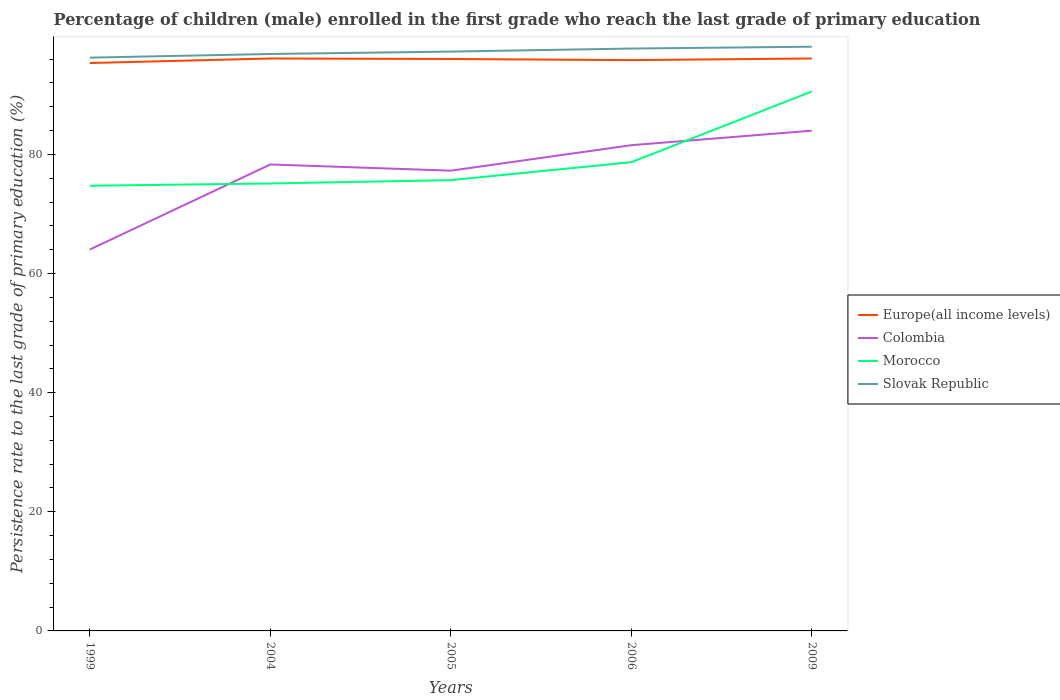How many different coloured lines are there?
Ensure brevity in your answer.  4. Is the number of lines equal to the number of legend labels?
Ensure brevity in your answer.  Yes. Across all years, what is the maximum persistence rate of children in Slovak Republic?
Offer a very short reply. 96.26. In which year was the persistence rate of children in Morocco maximum?
Provide a succinct answer. 1999. What is the total persistence rate of children in Morocco in the graph?
Offer a terse response. -3.01. What is the difference between the highest and the second highest persistence rate of children in Europe(all income levels)?
Your response must be concise. 0.76. How many years are there in the graph?
Your response must be concise. 5. What is the difference between two consecutive major ticks on the Y-axis?
Make the answer very short. 20. Are the values on the major ticks of Y-axis written in scientific E-notation?
Offer a very short reply. No. Does the graph contain any zero values?
Your answer should be compact. No. Does the graph contain grids?
Make the answer very short. No. How many legend labels are there?
Offer a terse response. 4. How are the legend labels stacked?
Your answer should be compact. Vertical. What is the title of the graph?
Keep it short and to the point. Percentage of children (male) enrolled in the first grade who reach the last grade of primary education. What is the label or title of the Y-axis?
Offer a terse response. Persistence rate to the last grade of primary education (%). What is the Persistence rate to the last grade of primary education (%) of Europe(all income levels) in 1999?
Your answer should be compact. 95.35. What is the Persistence rate to the last grade of primary education (%) in Colombia in 1999?
Ensure brevity in your answer.  64.04. What is the Persistence rate to the last grade of primary education (%) in Morocco in 1999?
Offer a very short reply. 74.75. What is the Persistence rate to the last grade of primary education (%) of Slovak Republic in 1999?
Make the answer very short. 96.26. What is the Persistence rate to the last grade of primary education (%) in Europe(all income levels) in 2004?
Make the answer very short. 96.11. What is the Persistence rate to the last grade of primary education (%) in Colombia in 2004?
Keep it short and to the point. 78.32. What is the Persistence rate to the last grade of primary education (%) of Morocco in 2004?
Ensure brevity in your answer.  75.13. What is the Persistence rate to the last grade of primary education (%) in Slovak Republic in 2004?
Your answer should be compact. 96.87. What is the Persistence rate to the last grade of primary education (%) in Europe(all income levels) in 2005?
Make the answer very short. 96.03. What is the Persistence rate to the last grade of primary education (%) of Colombia in 2005?
Make the answer very short. 77.28. What is the Persistence rate to the last grade of primary education (%) of Morocco in 2005?
Ensure brevity in your answer.  75.69. What is the Persistence rate to the last grade of primary education (%) in Slovak Republic in 2005?
Provide a short and direct response. 97.27. What is the Persistence rate to the last grade of primary education (%) in Europe(all income levels) in 2006?
Your response must be concise. 95.84. What is the Persistence rate to the last grade of primary education (%) of Colombia in 2006?
Offer a very short reply. 81.56. What is the Persistence rate to the last grade of primary education (%) in Morocco in 2006?
Offer a very short reply. 78.7. What is the Persistence rate to the last grade of primary education (%) of Slovak Republic in 2006?
Offer a terse response. 97.78. What is the Persistence rate to the last grade of primary education (%) of Europe(all income levels) in 2009?
Your response must be concise. 96.11. What is the Persistence rate to the last grade of primary education (%) in Colombia in 2009?
Make the answer very short. 83.99. What is the Persistence rate to the last grade of primary education (%) in Morocco in 2009?
Ensure brevity in your answer.  90.58. What is the Persistence rate to the last grade of primary education (%) in Slovak Republic in 2009?
Ensure brevity in your answer.  98.09. Across all years, what is the maximum Persistence rate to the last grade of primary education (%) in Europe(all income levels)?
Provide a succinct answer. 96.11. Across all years, what is the maximum Persistence rate to the last grade of primary education (%) in Colombia?
Ensure brevity in your answer.  83.99. Across all years, what is the maximum Persistence rate to the last grade of primary education (%) of Morocco?
Keep it short and to the point. 90.58. Across all years, what is the maximum Persistence rate to the last grade of primary education (%) in Slovak Republic?
Ensure brevity in your answer.  98.09. Across all years, what is the minimum Persistence rate to the last grade of primary education (%) of Europe(all income levels)?
Your response must be concise. 95.35. Across all years, what is the minimum Persistence rate to the last grade of primary education (%) in Colombia?
Provide a short and direct response. 64.04. Across all years, what is the minimum Persistence rate to the last grade of primary education (%) of Morocco?
Offer a terse response. 74.75. Across all years, what is the minimum Persistence rate to the last grade of primary education (%) in Slovak Republic?
Ensure brevity in your answer.  96.26. What is the total Persistence rate to the last grade of primary education (%) of Europe(all income levels) in the graph?
Make the answer very short. 479.45. What is the total Persistence rate to the last grade of primary education (%) of Colombia in the graph?
Offer a terse response. 385.19. What is the total Persistence rate to the last grade of primary education (%) of Morocco in the graph?
Give a very brief answer. 394.85. What is the total Persistence rate to the last grade of primary education (%) of Slovak Republic in the graph?
Make the answer very short. 486.27. What is the difference between the Persistence rate to the last grade of primary education (%) of Europe(all income levels) in 1999 and that in 2004?
Offer a very short reply. -0.76. What is the difference between the Persistence rate to the last grade of primary education (%) in Colombia in 1999 and that in 2004?
Provide a succinct answer. -14.28. What is the difference between the Persistence rate to the last grade of primary education (%) of Morocco in 1999 and that in 2004?
Provide a short and direct response. -0.38. What is the difference between the Persistence rate to the last grade of primary education (%) in Slovak Republic in 1999 and that in 2004?
Offer a very short reply. -0.61. What is the difference between the Persistence rate to the last grade of primary education (%) of Europe(all income levels) in 1999 and that in 2005?
Make the answer very short. -0.68. What is the difference between the Persistence rate to the last grade of primary education (%) of Colombia in 1999 and that in 2005?
Your answer should be very brief. -13.24. What is the difference between the Persistence rate to the last grade of primary education (%) of Morocco in 1999 and that in 2005?
Offer a terse response. -0.94. What is the difference between the Persistence rate to the last grade of primary education (%) in Slovak Republic in 1999 and that in 2005?
Your response must be concise. -1.02. What is the difference between the Persistence rate to the last grade of primary education (%) in Europe(all income levels) in 1999 and that in 2006?
Provide a succinct answer. -0.49. What is the difference between the Persistence rate to the last grade of primary education (%) of Colombia in 1999 and that in 2006?
Your answer should be compact. -17.52. What is the difference between the Persistence rate to the last grade of primary education (%) in Morocco in 1999 and that in 2006?
Make the answer very short. -3.95. What is the difference between the Persistence rate to the last grade of primary education (%) of Slovak Republic in 1999 and that in 2006?
Give a very brief answer. -1.53. What is the difference between the Persistence rate to the last grade of primary education (%) in Europe(all income levels) in 1999 and that in 2009?
Keep it short and to the point. -0.76. What is the difference between the Persistence rate to the last grade of primary education (%) of Colombia in 1999 and that in 2009?
Give a very brief answer. -19.95. What is the difference between the Persistence rate to the last grade of primary education (%) in Morocco in 1999 and that in 2009?
Ensure brevity in your answer.  -15.83. What is the difference between the Persistence rate to the last grade of primary education (%) of Slovak Republic in 1999 and that in 2009?
Your answer should be compact. -1.84. What is the difference between the Persistence rate to the last grade of primary education (%) in Europe(all income levels) in 2004 and that in 2005?
Your answer should be compact. 0.08. What is the difference between the Persistence rate to the last grade of primary education (%) in Colombia in 2004 and that in 2005?
Provide a succinct answer. 1.04. What is the difference between the Persistence rate to the last grade of primary education (%) in Morocco in 2004 and that in 2005?
Provide a succinct answer. -0.56. What is the difference between the Persistence rate to the last grade of primary education (%) of Slovak Republic in 2004 and that in 2005?
Ensure brevity in your answer.  -0.41. What is the difference between the Persistence rate to the last grade of primary education (%) in Europe(all income levels) in 2004 and that in 2006?
Provide a succinct answer. 0.27. What is the difference between the Persistence rate to the last grade of primary education (%) of Colombia in 2004 and that in 2006?
Offer a very short reply. -3.24. What is the difference between the Persistence rate to the last grade of primary education (%) of Morocco in 2004 and that in 2006?
Ensure brevity in your answer.  -3.57. What is the difference between the Persistence rate to the last grade of primary education (%) in Slovak Republic in 2004 and that in 2006?
Provide a short and direct response. -0.91. What is the difference between the Persistence rate to the last grade of primary education (%) in Europe(all income levels) in 2004 and that in 2009?
Provide a short and direct response. -0. What is the difference between the Persistence rate to the last grade of primary education (%) in Colombia in 2004 and that in 2009?
Your response must be concise. -5.67. What is the difference between the Persistence rate to the last grade of primary education (%) of Morocco in 2004 and that in 2009?
Offer a very short reply. -15.45. What is the difference between the Persistence rate to the last grade of primary education (%) of Slovak Republic in 2004 and that in 2009?
Provide a succinct answer. -1.22. What is the difference between the Persistence rate to the last grade of primary education (%) in Europe(all income levels) in 2005 and that in 2006?
Your response must be concise. 0.19. What is the difference between the Persistence rate to the last grade of primary education (%) in Colombia in 2005 and that in 2006?
Provide a succinct answer. -4.28. What is the difference between the Persistence rate to the last grade of primary education (%) of Morocco in 2005 and that in 2006?
Make the answer very short. -3.01. What is the difference between the Persistence rate to the last grade of primary education (%) of Slovak Republic in 2005 and that in 2006?
Your response must be concise. -0.51. What is the difference between the Persistence rate to the last grade of primary education (%) in Europe(all income levels) in 2005 and that in 2009?
Keep it short and to the point. -0.09. What is the difference between the Persistence rate to the last grade of primary education (%) of Colombia in 2005 and that in 2009?
Your answer should be compact. -6.71. What is the difference between the Persistence rate to the last grade of primary education (%) in Morocco in 2005 and that in 2009?
Give a very brief answer. -14.89. What is the difference between the Persistence rate to the last grade of primary education (%) of Slovak Republic in 2005 and that in 2009?
Your answer should be compact. -0.82. What is the difference between the Persistence rate to the last grade of primary education (%) of Europe(all income levels) in 2006 and that in 2009?
Offer a terse response. -0.28. What is the difference between the Persistence rate to the last grade of primary education (%) of Colombia in 2006 and that in 2009?
Your response must be concise. -2.44. What is the difference between the Persistence rate to the last grade of primary education (%) of Morocco in 2006 and that in 2009?
Give a very brief answer. -11.88. What is the difference between the Persistence rate to the last grade of primary education (%) in Slovak Republic in 2006 and that in 2009?
Provide a short and direct response. -0.31. What is the difference between the Persistence rate to the last grade of primary education (%) of Europe(all income levels) in 1999 and the Persistence rate to the last grade of primary education (%) of Colombia in 2004?
Your response must be concise. 17.03. What is the difference between the Persistence rate to the last grade of primary education (%) of Europe(all income levels) in 1999 and the Persistence rate to the last grade of primary education (%) of Morocco in 2004?
Ensure brevity in your answer.  20.22. What is the difference between the Persistence rate to the last grade of primary education (%) in Europe(all income levels) in 1999 and the Persistence rate to the last grade of primary education (%) in Slovak Republic in 2004?
Your response must be concise. -1.52. What is the difference between the Persistence rate to the last grade of primary education (%) of Colombia in 1999 and the Persistence rate to the last grade of primary education (%) of Morocco in 2004?
Offer a terse response. -11.09. What is the difference between the Persistence rate to the last grade of primary education (%) of Colombia in 1999 and the Persistence rate to the last grade of primary education (%) of Slovak Republic in 2004?
Keep it short and to the point. -32.83. What is the difference between the Persistence rate to the last grade of primary education (%) in Morocco in 1999 and the Persistence rate to the last grade of primary education (%) in Slovak Republic in 2004?
Provide a short and direct response. -22.12. What is the difference between the Persistence rate to the last grade of primary education (%) in Europe(all income levels) in 1999 and the Persistence rate to the last grade of primary education (%) in Colombia in 2005?
Your answer should be very brief. 18.07. What is the difference between the Persistence rate to the last grade of primary education (%) of Europe(all income levels) in 1999 and the Persistence rate to the last grade of primary education (%) of Morocco in 2005?
Provide a short and direct response. 19.66. What is the difference between the Persistence rate to the last grade of primary education (%) in Europe(all income levels) in 1999 and the Persistence rate to the last grade of primary education (%) in Slovak Republic in 2005?
Offer a terse response. -1.92. What is the difference between the Persistence rate to the last grade of primary education (%) in Colombia in 1999 and the Persistence rate to the last grade of primary education (%) in Morocco in 2005?
Offer a very short reply. -11.65. What is the difference between the Persistence rate to the last grade of primary education (%) of Colombia in 1999 and the Persistence rate to the last grade of primary education (%) of Slovak Republic in 2005?
Offer a very short reply. -33.24. What is the difference between the Persistence rate to the last grade of primary education (%) in Morocco in 1999 and the Persistence rate to the last grade of primary education (%) in Slovak Republic in 2005?
Keep it short and to the point. -22.52. What is the difference between the Persistence rate to the last grade of primary education (%) of Europe(all income levels) in 1999 and the Persistence rate to the last grade of primary education (%) of Colombia in 2006?
Offer a very short reply. 13.8. What is the difference between the Persistence rate to the last grade of primary education (%) in Europe(all income levels) in 1999 and the Persistence rate to the last grade of primary education (%) in Morocco in 2006?
Provide a succinct answer. 16.65. What is the difference between the Persistence rate to the last grade of primary education (%) of Europe(all income levels) in 1999 and the Persistence rate to the last grade of primary education (%) of Slovak Republic in 2006?
Provide a short and direct response. -2.43. What is the difference between the Persistence rate to the last grade of primary education (%) of Colombia in 1999 and the Persistence rate to the last grade of primary education (%) of Morocco in 2006?
Offer a terse response. -14.66. What is the difference between the Persistence rate to the last grade of primary education (%) of Colombia in 1999 and the Persistence rate to the last grade of primary education (%) of Slovak Republic in 2006?
Provide a succinct answer. -33.74. What is the difference between the Persistence rate to the last grade of primary education (%) in Morocco in 1999 and the Persistence rate to the last grade of primary education (%) in Slovak Republic in 2006?
Give a very brief answer. -23.03. What is the difference between the Persistence rate to the last grade of primary education (%) in Europe(all income levels) in 1999 and the Persistence rate to the last grade of primary education (%) in Colombia in 2009?
Provide a short and direct response. 11.36. What is the difference between the Persistence rate to the last grade of primary education (%) in Europe(all income levels) in 1999 and the Persistence rate to the last grade of primary education (%) in Morocco in 2009?
Offer a very short reply. 4.77. What is the difference between the Persistence rate to the last grade of primary education (%) of Europe(all income levels) in 1999 and the Persistence rate to the last grade of primary education (%) of Slovak Republic in 2009?
Offer a very short reply. -2.74. What is the difference between the Persistence rate to the last grade of primary education (%) in Colombia in 1999 and the Persistence rate to the last grade of primary education (%) in Morocco in 2009?
Offer a terse response. -26.54. What is the difference between the Persistence rate to the last grade of primary education (%) of Colombia in 1999 and the Persistence rate to the last grade of primary education (%) of Slovak Republic in 2009?
Your response must be concise. -34.05. What is the difference between the Persistence rate to the last grade of primary education (%) in Morocco in 1999 and the Persistence rate to the last grade of primary education (%) in Slovak Republic in 2009?
Give a very brief answer. -23.34. What is the difference between the Persistence rate to the last grade of primary education (%) of Europe(all income levels) in 2004 and the Persistence rate to the last grade of primary education (%) of Colombia in 2005?
Offer a very short reply. 18.83. What is the difference between the Persistence rate to the last grade of primary education (%) in Europe(all income levels) in 2004 and the Persistence rate to the last grade of primary education (%) in Morocco in 2005?
Give a very brief answer. 20.42. What is the difference between the Persistence rate to the last grade of primary education (%) in Europe(all income levels) in 2004 and the Persistence rate to the last grade of primary education (%) in Slovak Republic in 2005?
Your response must be concise. -1.16. What is the difference between the Persistence rate to the last grade of primary education (%) of Colombia in 2004 and the Persistence rate to the last grade of primary education (%) of Morocco in 2005?
Keep it short and to the point. 2.63. What is the difference between the Persistence rate to the last grade of primary education (%) in Colombia in 2004 and the Persistence rate to the last grade of primary education (%) in Slovak Republic in 2005?
Offer a very short reply. -18.96. What is the difference between the Persistence rate to the last grade of primary education (%) in Morocco in 2004 and the Persistence rate to the last grade of primary education (%) in Slovak Republic in 2005?
Your answer should be compact. -22.15. What is the difference between the Persistence rate to the last grade of primary education (%) in Europe(all income levels) in 2004 and the Persistence rate to the last grade of primary education (%) in Colombia in 2006?
Give a very brief answer. 14.55. What is the difference between the Persistence rate to the last grade of primary education (%) of Europe(all income levels) in 2004 and the Persistence rate to the last grade of primary education (%) of Morocco in 2006?
Provide a short and direct response. 17.41. What is the difference between the Persistence rate to the last grade of primary education (%) of Europe(all income levels) in 2004 and the Persistence rate to the last grade of primary education (%) of Slovak Republic in 2006?
Ensure brevity in your answer.  -1.67. What is the difference between the Persistence rate to the last grade of primary education (%) of Colombia in 2004 and the Persistence rate to the last grade of primary education (%) of Morocco in 2006?
Offer a very short reply. -0.38. What is the difference between the Persistence rate to the last grade of primary education (%) of Colombia in 2004 and the Persistence rate to the last grade of primary education (%) of Slovak Republic in 2006?
Your answer should be very brief. -19.46. What is the difference between the Persistence rate to the last grade of primary education (%) in Morocco in 2004 and the Persistence rate to the last grade of primary education (%) in Slovak Republic in 2006?
Offer a terse response. -22.65. What is the difference between the Persistence rate to the last grade of primary education (%) of Europe(all income levels) in 2004 and the Persistence rate to the last grade of primary education (%) of Colombia in 2009?
Offer a terse response. 12.12. What is the difference between the Persistence rate to the last grade of primary education (%) in Europe(all income levels) in 2004 and the Persistence rate to the last grade of primary education (%) in Morocco in 2009?
Your response must be concise. 5.53. What is the difference between the Persistence rate to the last grade of primary education (%) in Europe(all income levels) in 2004 and the Persistence rate to the last grade of primary education (%) in Slovak Republic in 2009?
Provide a short and direct response. -1.98. What is the difference between the Persistence rate to the last grade of primary education (%) of Colombia in 2004 and the Persistence rate to the last grade of primary education (%) of Morocco in 2009?
Offer a very short reply. -12.26. What is the difference between the Persistence rate to the last grade of primary education (%) of Colombia in 2004 and the Persistence rate to the last grade of primary education (%) of Slovak Republic in 2009?
Provide a succinct answer. -19.77. What is the difference between the Persistence rate to the last grade of primary education (%) in Morocco in 2004 and the Persistence rate to the last grade of primary education (%) in Slovak Republic in 2009?
Offer a terse response. -22.96. What is the difference between the Persistence rate to the last grade of primary education (%) in Europe(all income levels) in 2005 and the Persistence rate to the last grade of primary education (%) in Colombia in 2006?
Your answer should be compact. 14.47. What is the difference between the Persistence rate to the last grade of primary education (%) of Europe(all income levels) in 2005 and the Persistence rate to the last grade of primary education (%) of Morocco in 2006?
Give a very brief answer. 17.33. What is the difference between the Persistence rate to the last grade of primary education (%) of Europe(all income levels) in 2005 and the Persistence rate to the last grade of primary education (%) of Slovak Republic in 2006?
Provide a short and direct response. -1.75. What is the difference between the Persistence rate to the last grade of primary education (%) of Colombia in 2005 and the Persistence rate to the last grade of primary education (%) of Morocco in 2006?
Your answer should be very brief. -1.42. What is the difference between the Persistence rate to the last grade of primary education (%) in Colombia in 2005 and the Persistence rate to the last grade of primary education (%) in Slovak Republic in 2006?
Provide a short and direct response. -20.5. What is the difference between the Persistence rate to the last grade of primary education (%) of Morocco in 2005 and the Persistence rate to the last grade of primary education (%) of Slovak Republic in 2006?
Provide a short and direct response. -22.09. What is the difference between the Persistence rate to the last grade of primary education (%) of Europe(all income levels) in 2005 and the Persistence rate to the last grade of primary education (%) of Colombia in 2009?
Your answer should be very brief. 12.04. What is the difference between the Persistence rate to the last grade of primary education (%) in Europe(all income levels) in 2005 and the Persistence rate to the last grade of primary education (%) in Morocco in 2009?
Offer a terse response. 5.45. What is the difference between the Persistence rate to the last grade of primary education (%) in Europe(all income levels) in 2005 and the Persistence rate to the last grade of primary education (%) in Slovak Republic in 2009?
Offer a terse response. -2.06. What is the difference between the Persistence rate to the last grade of primary education (%) in Colombia in 2005 and the Persistence rate to the last grade of primary education (%) in Morocco in 2009?
Give a very brief answer. -13.3. What is the difference between the Persistence rate to the last grade of primary education (%) of Colombia in 2005 and the Persistence rate to the last grade of primary education (%) of Slovak Republic in 2009?
Give a very brief answer. -20.81. What is the difference between the Persistence rate to the last grade of primary education (%) in Morocco in 2005 and the Persistence rate to the last grade of primary education (%) in Slovak Republic in 2009?
Your answer should be very brief. -22.4. What is the difference between the Persistence rate to the last grade of primary education (%) of Europe(all income levels) in 2006 and the Persistence rate to the last grade of primary education (%) of Colombia in 2009?
Ensure brevity in your answer.  11.85. What is the difference between the Persistence rate to the last grade of primary education (%) of Europe(all income levels) in 2006 and the Persistence rate to the last grade of primary education (%) of Morocco in 2009?
Make the answer very short. 5.26. What is the difference between the Persistence rate to the last grade of primary education (%) of Europe(all income levels) in 2006 and the Persistence rate to the last grade of primary education (%) of Slovak Republic in 2009?
Make the answer very short. -2.25. What is the difference between the Persistence rate to the last grade of primary education (%) in Colombia in 2006 and the Persistence rate to the last grade of primary education (%) in Morocco in 2009?
Provide a short and direct response. -9.02. What is the difference between the Persistence rate to the last grade of primary education (%) in Colombia in 2006 and the Persistence rate to the last grade of primary education (%) in Slovak Republic in 2009?
Offer a terse response. -16.53. What is the difference between the Persistence rate to the last grade of primary education (%) in Morocco in 2006 and the Persistence rate to the last grade of primary education (%) in Slovak Republic in 2009?
Offer a very short reply. -19.39. What is the average Persistence rate to the last grade of primary education (%) of Europe(all income levels) per year?
Make the answer very short. 95.89. What is the average Persistence rate to the last grade of primary education (%) in Colombia per year?
Make the answer very short. 77.04. What is the average Persistence rate to the last grade of primary education (%) of Morocco per year?
Offer a terse response. 78.97. What is the average Persistence rate to the last grade of primary education (%) of Slovak Republic per year?
Your answer should be very brief. 97.25. In the year 1999, what is the difference between the Persistence rate to the last grade of primary education (%) in Europe(all income levels) and Persistence rate to the last grade of primary education (%) in Colombia?
Provide a short and direct response. 31.31. In the year 1999, what is the difference between the Persistence rate to the last grade of primary education (%) of Europe(all income levels) and Persistence rate to the last grade of primary education (%) of Morocco?
Your answer should be compact. 20.6. In the year 1999, what is the difference between the Persistence rate to the last grade of primary education (%) in Europe(all income levels) and Persistence rate to the last grade of primary education (%) in Slovak Republic?
Give a very brief answer. -0.9. In the year 1999, what is the difference between the Persistence rate to the last grade of primary education (%) in Colombia and Persistence rate to the last grade of primary education (%) in Morocco?
Your answer should be compact. -10.71. In the year 1999, what is the difference between the Persistence rate to the last grade of primary education (%) of Colombia and Persistence rate to the last grade of primary education (%) of Slovak Republic?
Ensure brevity in your answer.  -32.22. In the year 1999, what is the difference between the Persistence rate to the last grade of primary education (%) in Morocco and Persistence rate to the last grade of primary education (%) in Slovak Republic?
Provide a succinct answer. -21.5. In the year 2004, what is the difference between the Persistence rate to the last grade of primary education (%) of Europe(all income levels) and Persistence rate to the last grade of primary education (%) of Colombia?
Your response must be concise. 17.79. In the year 2004, what is the difference between the Persistence rate to the last grade of primary education (%) of Europe(all income levels) and Persistence rate to the last grade of primary education (%) of Morocco?
Make the answer very short. 20.98. In the year 2004, what is the difference between the Persistence rate to the last grade of primary education (%) in Europe(all income levels) and Persistence rate to the last grade of primary education (%) in Slovak Republic?
Keep it short and to the point. -0.76. In the year 2004, what is the difference between the Persistence rate to the last grade of primary education (%) in Colombia and Persistence rate to the last grade of primary education (%) in Morocco?
Offer a very short reply. 3.19. In the year 2004, what is the difference between the Persistence rate to the last grade of primary education (%) in Colombia and Persistence rate to the last grade of primary education (%) in Slovak Republic?
Make the answer very short. -18.55. In the year 2004, what is the difference between the Persistence rate to the last grade of primary education (%) in Morocco and Persistence rate to the last grade of primary education (%) in Slovak Republic?
Make the answer very short. -21.74. In the year 2005, what is the difference between the Persistence rate to the last grade of primary education (%) of Europe(all income levels) and Persistence rate to the last grade of primary education (%) of Colombia?
Give a very brief answer. 18.75. In the year 2005, what is the difference between the Persistence rate to the last grade of primary education (%) of Europe(all income levels) and Persistence rate to the last grade of primary education (%) of Morocco?
Provide a succinct answer. 20.34. In the year 2005, what is the difference between the Persistence rate to the last grade of primary education (%) of Europe(all income levels) and Persistence rate to the last grade of primary education (%) of Slovak Republic?
Ensure brevity in your answer.  -1.25. In the year 2005, what is the difference between the Persistence rate to the last grade of primary education (%) of Colombia and Persistence rate to the last grade of primary education (%) of Morocco?
Your answer should be compact. 1.59. In the year 2005, what is the difference between the Persistence rate to the last grade of primary education (%) of Colombia and Persistence rate to the last grade of primary education (%) of Slovak Republic?
Offer a terse response. -20. In the year 2005, what is the difference between the Persistence rate to the last grade of primary education (%) in Morocco and Persistence rate to the last grade of primary education (%) in Slovak Republic?
Offer a terse response. -21.58. In the year 2006, what is the difference between the Persistence rate to the last grade of primary education (%) in Europe(all income levels) and Persistence rate to the last grade of primary education (%) in Colombia?
Keep it short and to the point. 14.28. In the year 2006, what is the difference between the Persistence rate to the last grade of primary education (%) of Europe(all income levels) and Persistence rate to the last grade of primary education (%) of Morocco?
Ensure brevity in your answer.  17.14. In the year 2006, what is the difference between the Persistence rate to the last grade of primary education (%) in Europe(all income levels) and Persistence rate to the last grade of primary education (%) in Slovak Republic?
Your response must be concise. -1.94. In the year 2006, what is the difference between the Persistence rate to the last grade of primary education (%) of Colombia and Persistence rate to the last grade of primary education (%) of Morocco?
Make the answer very short. 2.86. In the year 2006, what is the difference between the Persistence rate to the last grade of primary education (%) in Colombia and Persistence rate to the last grade of primary education (%) in Slovak Republic?
Your response must be concise. -16.23. In the year 2006, what is the difference between the Persistence rate to the last grade of primary education (%) of Morocco and Persistence rate to the last grade of primary education (%) of Slovak Republic?
Ensure brevity in your answer.  -19.08. In the year 2009, what is the difference between the Persistence rate to the last grade of primary education (%) of Europe(all income levels) and Persistence rate to the last grade of primary education (%) of Colombia?
Your response must be concise. 12.12. In the year 2009, what is the difference between the Persistence rate to the last grade of primary education (%) in Europe(all income levels) and Persistence rate to the last grade of primary education (%) in Morocco?
Your answer should be very brief. 5.53. In the year 2009, what is the difference between the Persistence rate to the last grade of primary education (%) of Europe(all income levels) and Persistence rate to the last grade of primary education (%) of Slovak Republic?
Give a very brief answer. -1.98. In the year 2009, what is the difference between the Persistence rate to the last grade of primary education (%) in Colombia and Persistence rate to the last grade of primary education (%) in Morocco?
Your response must be concise. -6.59. In the year 2009, what is the difference between the Persistence rate to the last grade of primary education (%) in Colombia and Persistence rate to the last grade of primary education (%) in Slovak Republic?
Provide a short and direct response. -14.1. In the year 2009, what is the difference between the Persistence rate to the last grade of primary education (%) in Morocco and Persistence rate to the last grade of primary education (%) in Slovak Republic?
Your response must be concise. -7.51. What is the ratio of the Persistence rate to the last grade of primary education (%) of Europe(all income levels) in 1999 to that in 2004?
Provide a succinct answer. 0.99. What is the ratio of the Persistence rate to the last grade of primary education (%) of Colombia in 1999 to that in 2004?
Provide a short and direct response. 0.82. What is the ratio of the Persistence rate to the last grade of primary education (%) of Morocco in 1999 to that in 2004?
Your response must be concise. 0.99. What is the ratio of the Persistence rate to the last grade of primary education (%) in Slovak Republic in 1999 to that in 2004?
Keep it short and to the point. 0.99. What is the ratio of the Persistence rate to the last grade of primary education (%) of Colombia in 1999 to that in 2005?
Your answer should be compact. 0.83. What is the ratio of the Persistence rate to the last grade of primary education (%) of Morocco in 1999 to that in 2005?
Ensure brevity in your answer.  0.99. What is the ratio of the Persistence rate to the last grade of primary education (%) of Colombia in 1999 to that in 2006?
Your answer should be very brief. 0.79. What is the ratio of the Persistence rate to the last grade of primary education (%) in Morocco in 1999 to that in 2006?
Provide a short and direct response. 0.95. What is the ratio of the Persistence rate to the last grade of primary education (%) in Slovak Republic in 1999 to that in 2006?
Your answer should be very brief. 0.98. What is the ratio of the Persistence rate to the last grade of primary education (%) in Europe(all income levels) in 1999 to that in 2009?
Your answer should be very brief. 0.99. What is the ratio of the Persistence rate to the last grade of primary education (%) in Colombia in 1999 to that in 2009?
Your answer should be very brief. 0.76. What is the ratio of the Persistence rate to the last grade of primary education (%) of Morocco in 1999 to that in 2009?
Ensure brevity in your answer.  0.83. What is the ratio of the Persistence rate to the last grade of primary education (%) in Slovak Republic in 1999 to that in 2009?
Give a very brief answer. 0.98. What is the ratio of the Persistence rate to the last grade of primary education (%) in Colombia in 2004 to that in 2005?
Provide a short and direct response. 1.01. What is the ratio of the Persistence rate to the last grade of primary education (%) of Morocco in 2004 to that in 2005?
Your answer should be compact. 0.99. What is the ratio of the Persistence rate to the last grade of primary education (%) of Slovak Republic in 2004 to that in 2005?
Give a very brief answer. 1. What is the ratio of the Persistence rate to the last grade of primary education (%) in Colombia in 2004 to that in 2006?
Make the answer very short. 0.96. What is the ratio of the Persistence rate to the last grade of primary education (%) in Morocco in 2004 to that in 2006?
Your answer should be very brief. 0.95. What is the ratio of the Persistence rate to the last grade of primary education (%) of Slovak Republic in 2004 to that in 2006?
Ensure brevity in your answer.  0.99. What is the ratio of the Persistence rate to the last grade of primary education (%) of Colombia in 2004 to that in 2009?
Offer a very short reply. 0.93. What is the ratio of the Persistence rate to the last grade of primary education (%) of Morocco in 2004 to that in 2009?
Offer a very short reply. 0.83. What is the ratio of the Persistence rate to the last grade of primary education (%) in Slovak Republic in 2004 to that in 2009?
Ensure brevity in your answer.  0.99. What is the ratio of the Persistence rate to the last grade of primary education (%) in Europe(all income levels) in 2005 to that in 2006?
Offer a terse response. 1. What is the ratio of the Persistence rate to the last grade of primary education (%) in Colombia in 2005 to that in 2006?
Ensure brevity in your answer.  0.95. What is the ratio of the Persistence rate to the last grade of primary education (%) in Morocco in 2005 to that in 2006?
Keep it short and to the point. 0.96. What is the ratio of the Persistence rate to the last grade of primary education (%) of Colombia in 2005 to that in 2009?
Offer a very short reply. 0.92. What is the ratio of the Persistence rate to the last grade of primary education (%) of Morocco in 2005 to that in 2009?
Your response must be concise. 0.84. What is the ratio of the Persistence rate to the last grade of primary education (%) in Slovak Republic in 2005 to that in 2009?
Your answer should be very brief. 0.99. What is the ratio of the Persistence rate to the last grade of primary education (%) in Colombia in 2006 to that in 2009?
Your response must be concise. 0.97. What is the ratio of the Persistence rate to the last grade of primary education (%) of Morocco in 2006 to that in 2009?
Your answer should be compact. 0.87. What is the ratio of the Persistence rate to the last grade of primary education (%) in Slovak Republic in 2006 to that in 2009?
Offer a very short reply. 1. What is the difference between the highest and the second highest Persistence rate to the last grade of primary education (%) in Europe(all income levels)?
Your answer should be very brief. 0. What is the difference between the highest and the second highest Persistence rate to the last grade of primary education (%) of Colombia?
Your answer should be compact. 2.44. What is the difference between the highest and the second highest Persistence rate to the last grade of primary education (%) of Morocco?
Provide a short and direct response. 11.88. What is the difference between the highest and the second highest Persistence rate to the last grade of primary education (%) of Slovak Republic?
Ensure brevity in your answer.  0.31. What is the difference between the highest and the lowest Persistence rate to the last grade of primary education (%) of Europe(all income levels)?
Your response must be concise. 0.76. What is the difference between the highest and the lowest Persistence rate to the last grade of primary education (%) of Colombia?
Keep it short and to the point. 19.95. What is the difference between the highest and the lowest Persistence rate to the last grade of primary education (%) in Morocco?
Your answer should be compact. 15.83. What is the difference between the highest and the lowest Persistence rate to the last grade of primary education (%) in Slovak Republic?
Offer a terse response. 1.84. 